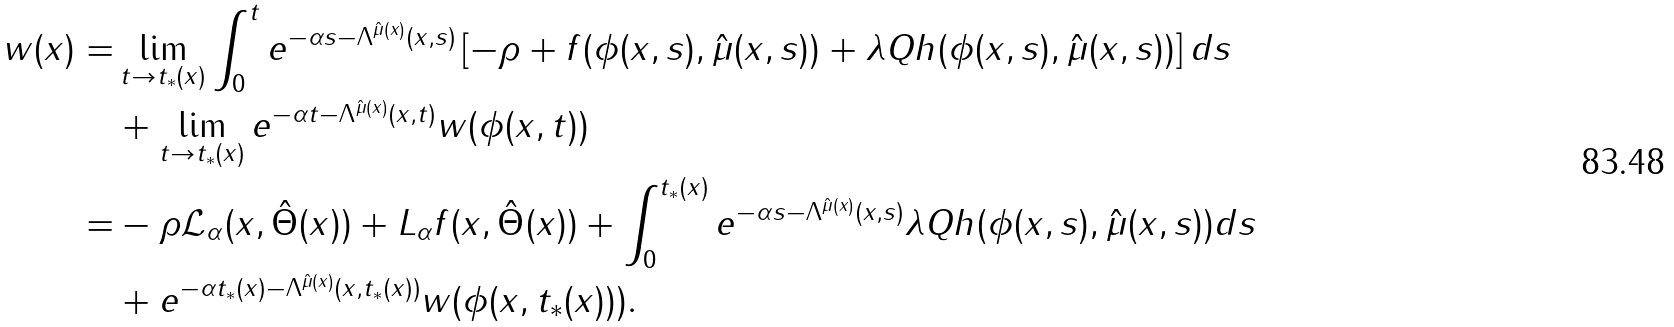<formula> <loc_0><loc_0><loc_500><loc_500>w ( x ) = & \lim _ { t \rightarrow t _ { * } ( x ) } \int _ { 0 } ^ { t } e ^ { - \alpha s - \Lambda ^ { \hat { \mu } ( x ) } ( x , s ) } \left [ - \rho + f ( \phi ( x , s ) , \hat { \mu } ( x , s ) ) + \lambda Q h ( \phi ( x , s ) , \hat { \mu } ( x , s ) ) \right ] d s \\ & + \lim _ { t \rightarrow t _ { * } ( x ) } e ^ { - \alpha t - \Lambda ^ { \hat { \mu } ( x ) } ( x , t ) } w ( \phi ( x , t ) ) \\ = & - \rho \mathcal { L } _ { \alpha } ( x , \hat { \Theta } ( x ) ) + L _ { \alpha } f ( x , \hat { \Theta } ( x ) ) + \int _ { 0 } ^ { t _ { * } ( x ) } e ^ { - \alpha s - \Lambda ^ { \hat { \mu } ( x ) } ( x , s ) } \lambda Q h ( \phi ( x , s ) , \hat { \mu } ( x , s ) ) d s \\ & + e ^ { - \alpha t _ { * } ( x ) - \Lambda ^ { \hat { \mu } ( x ) } ( x , t _ { * } ( x ) ) } w ( \phi ( x , t _ { * } ( x ) ) ) .</formula> 